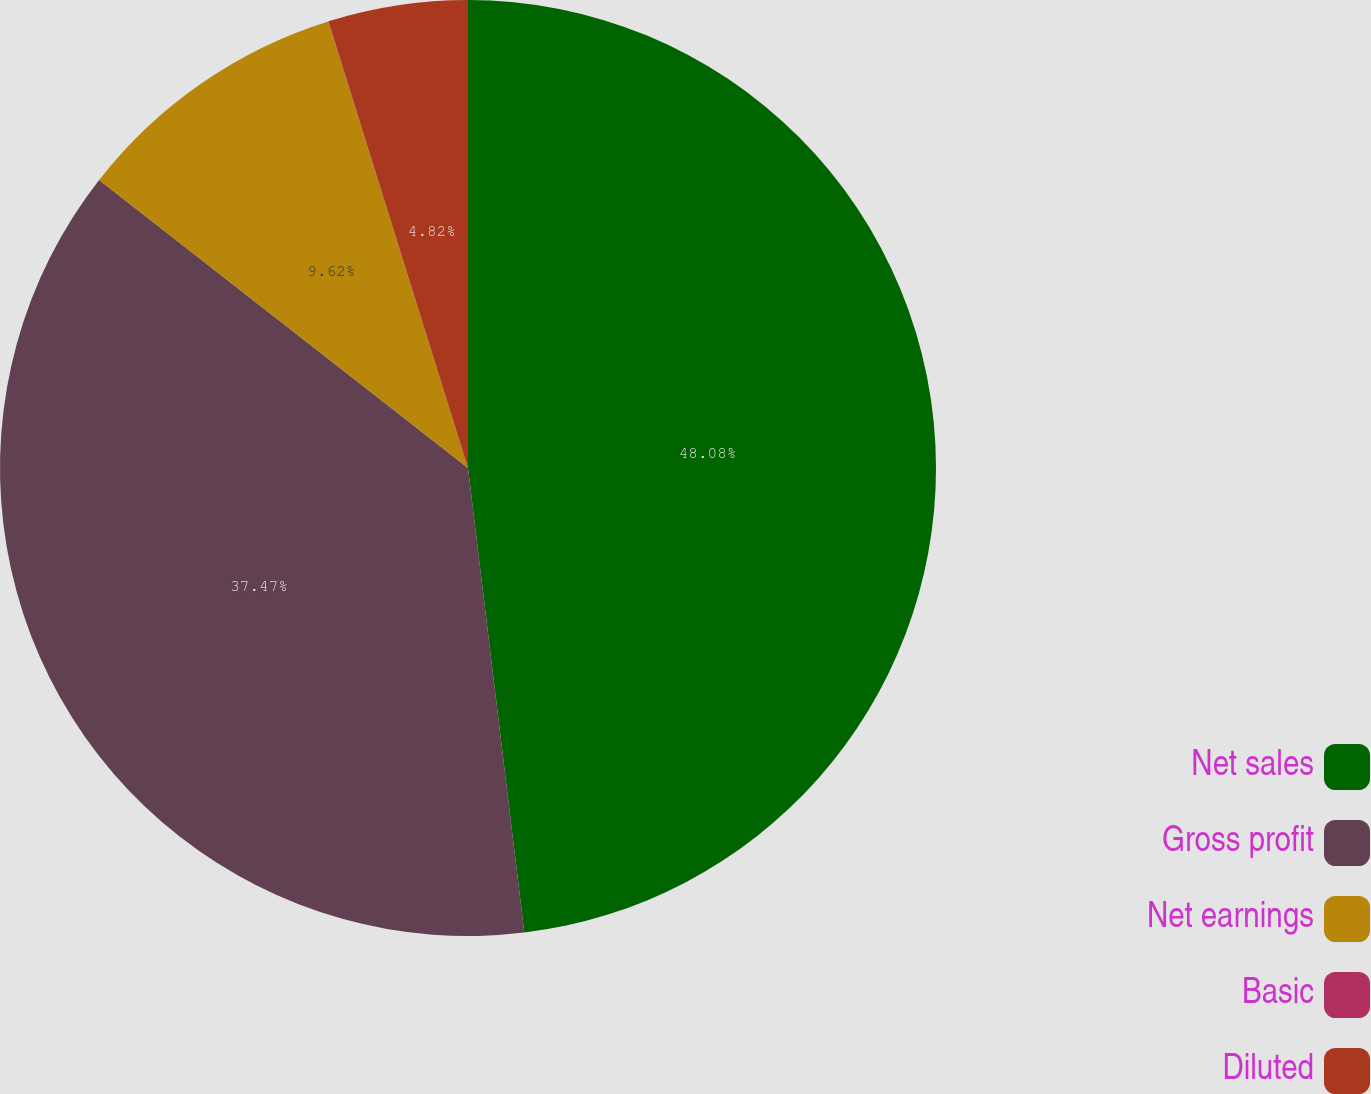<chart> <loc_0><loc_0><loc_500><loc_500><pie_chart><fcel>Net sales<fcel>Gross profit<fcel>Net earnings<fcel>Basic<fcel>Diluted<nl><fcel>48.08%<fcel>37.47%<fcel>9.62%<fcel>0.01%<fcel>4.82%<nl></chart> 